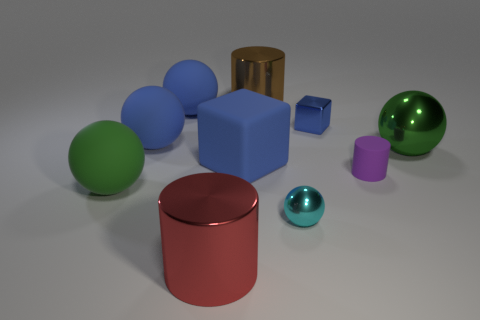What is the material of the cyan object?
Give a very brief answer. Metal. Are there any other things that have the same size as the cyan metal ball?
Your answer should be very brief. Yes. What size is the green metallic thing that is the same shape as the green matte thing?
Keep it short and to the point. Large. Are there any rubber things behind the large blue sphere that is behind the blue metal thing?
Give a very brief answer. No. Is the color of the large matte block the same as the shiny cube?
Ensure brevity in your answer.  Yes. How many other objects are there of the same shape as the purple object?
Your answer should be compact. 2. Are there more green metallic spheres behind the big brown object than big red things behind the small purple rubber thing?
Your answer should be compact. No. Is the size of the green thing that is on the left side of the purple thing the same as the green sphere right of the brown thing?
Give a very brief answer. Yes. What is the shape of the red metal thing?
Keep it short and to the point. Cylinder. What size is the other cube that is the same color as the shiny block?
Provide a short and direct response. Large. 